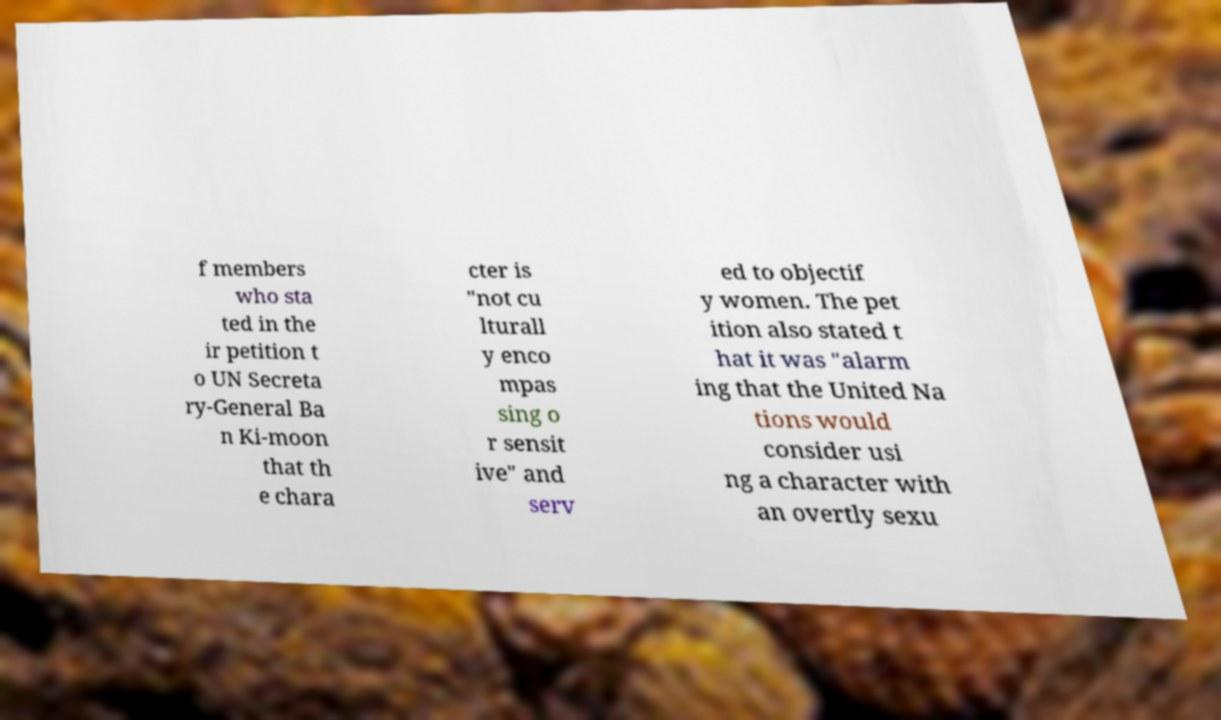What messages or text are displayed in this image? I need them in a readable, typed format. f members who sta ted in the ir petition t o UN Secreta ry-General Ba n Ki-moon that th e chara cter is "not cu lturall y enco mpas sing o r sensit ive" and serv ed to objectif y women. The pet ition also stated t hat it was "alarm ing that the United Na tions would consider usi ng a character with an overtly sexu 